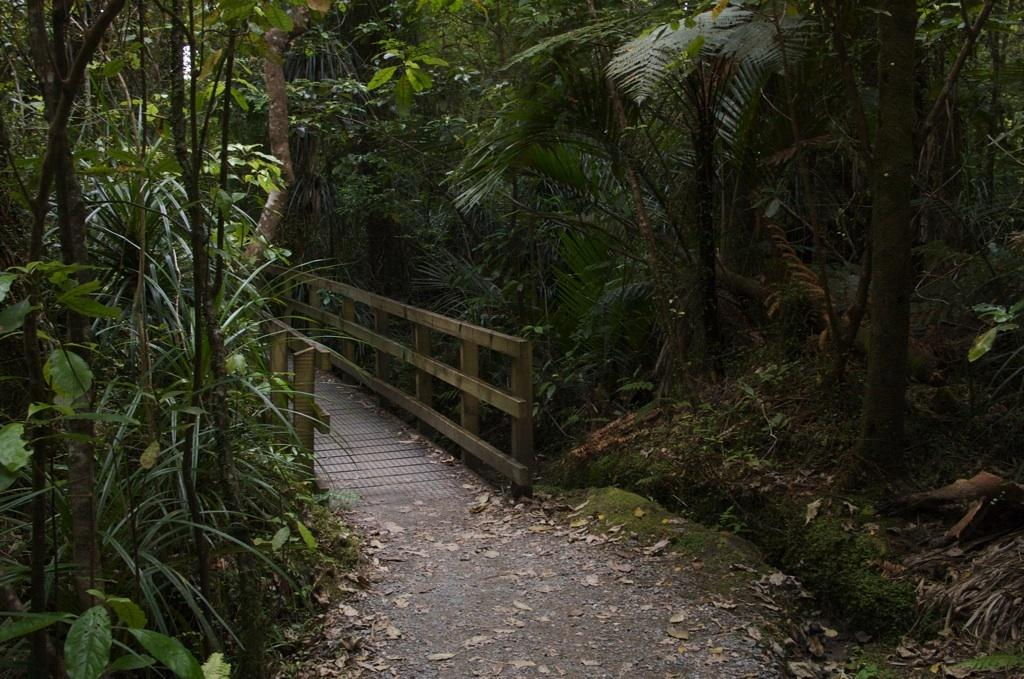What structure is located in the center of the image? There is a wooden bridge in the center of the image. What can be seen in the background of the image? There is a group of trees in the background of the image. What type of advertisement can be seen hanging on the bridge in the image? There is no advertisement present on the bridge in the image. What type of quilt is draped over the bed in the image? There is no bed or quilt present in the image; it features a wooden bridge and a group of trees in the background. 